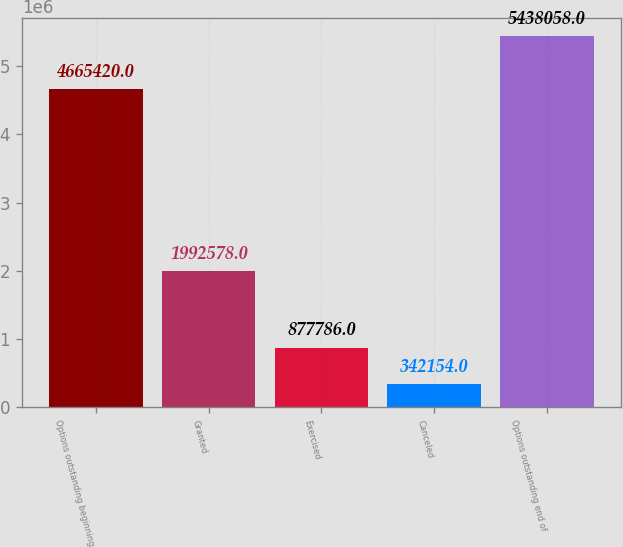Convert chart to OTSL. <chart><loc_0><loc_0><loc_500><loc_500><bar_chart><fcel>Options outstanding beginning<fcel>Granted<fcel>Exercised<fcel>Canceled<fcel>Options outstanding end of<nl><fcel>4.66542e+06<fcel>1.99258e+06<fcel>877786<fcel>342154<fcel>5.43806e+06<nl></chart> 